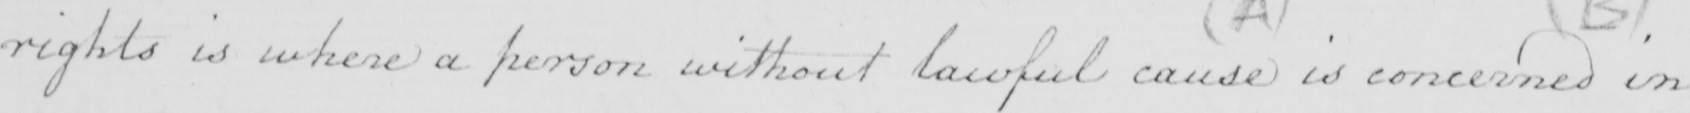What text is written in this handwritten line? rights is where a person without lawful cause is concerned in 